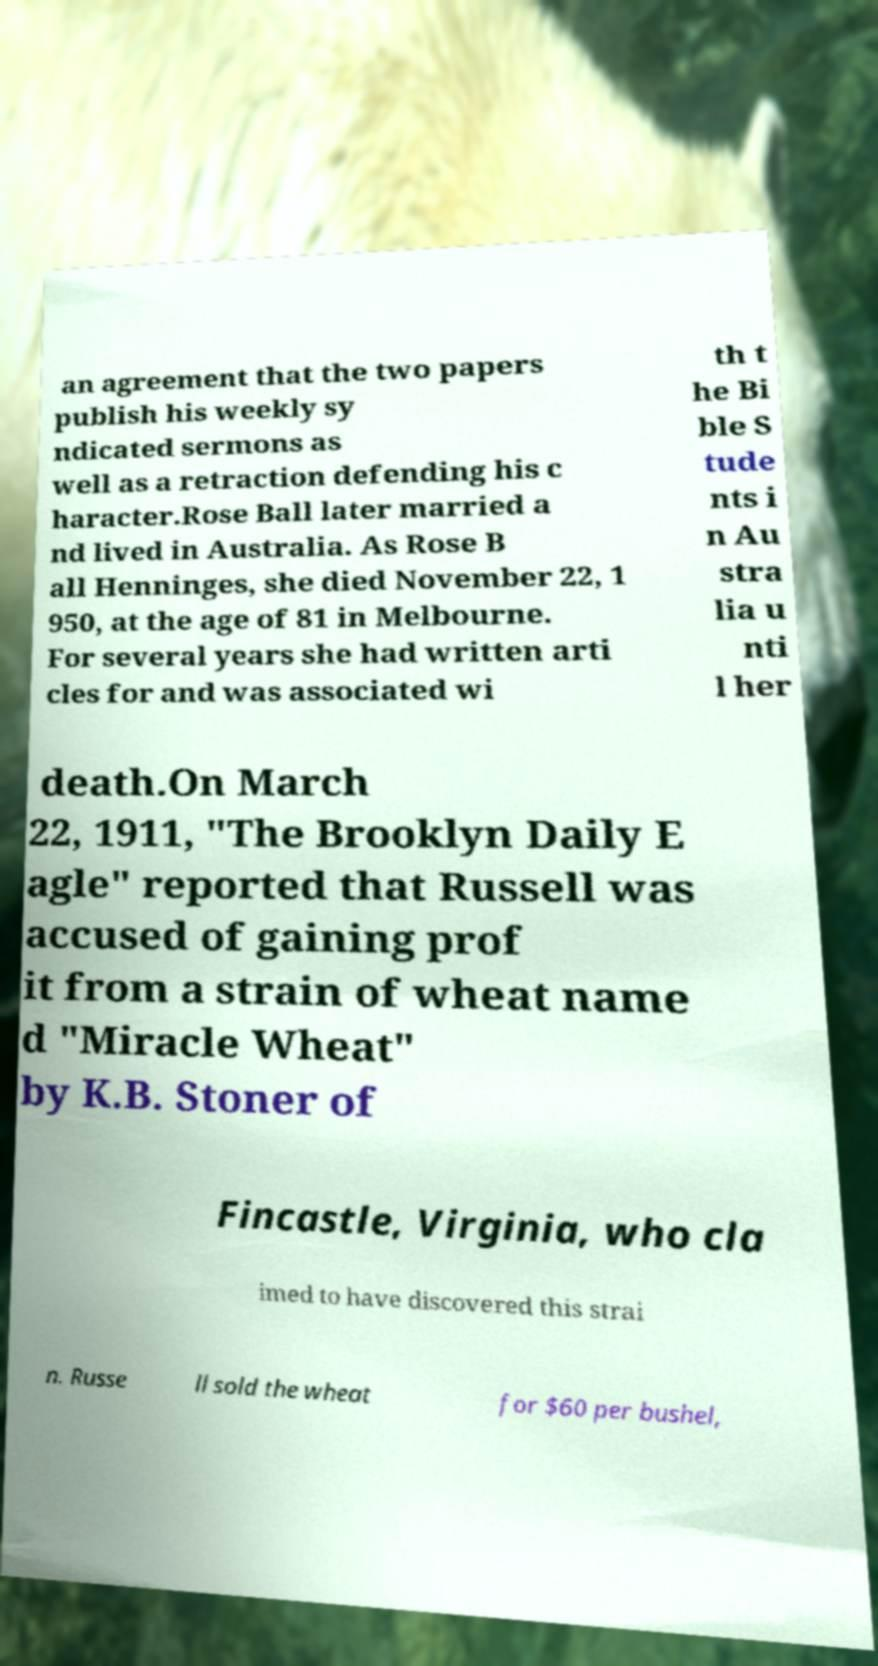What messages or text are displayed in this image? I need them in a readable, typed format. an agreement that the two papers publish his weekly sy ndicated sermons as well as a retraction defending his c haracter.Rose Ball later married a nd lived in Australia. As Rose B all Henninges, she died November 22, 1 950, at the age of 81 in Melbourne. For several years she had written arti cles for and was associated wi th t he Bi ble S tude nts i n Au stra lia u nti l her death.On March 22, 1911, "The Brooklyn Daily E agle" reported that Russell was accused of gaining prof it from a strain of wheat name d "Miracle Wheat" by K.B. Stoner of Fincastle, Virginia, who cla imed to have discovered this strai n. Russe ll sold the wheat for $60 per bushel, 